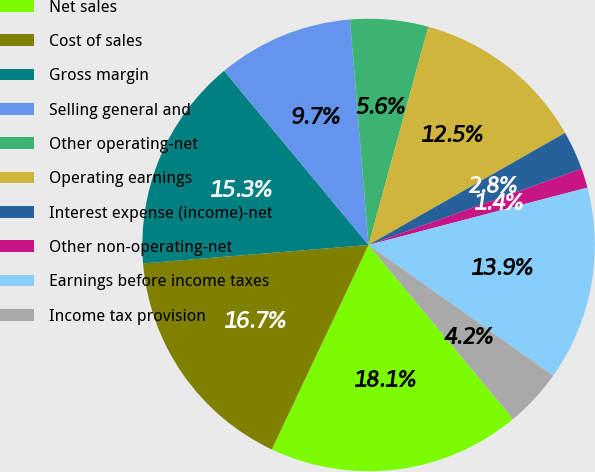Convert chart. <chart><loc_0><loc_0><loc_500><loc_500><pie_chart><fcel>Net sales<fcel>Cost of sales<fcel>Gross margin<fcel>Selling general and<fcel>Other operating-net<fcel>Operating earnings<fcel>Interest expense (income)-net<fcel>Other non-operating-net<fcel>Earnings before income taxes<fcel>Income tax provision<nl><fcel>18.06%<fcel>16.67%<fcel>15.28%<fcel>9.72%<fcel>5.56%<fcel>12.5%<fcel>2.78%<fcel>1.39%<fcel>13.89%<fcel>4.17%<nl></chart> 